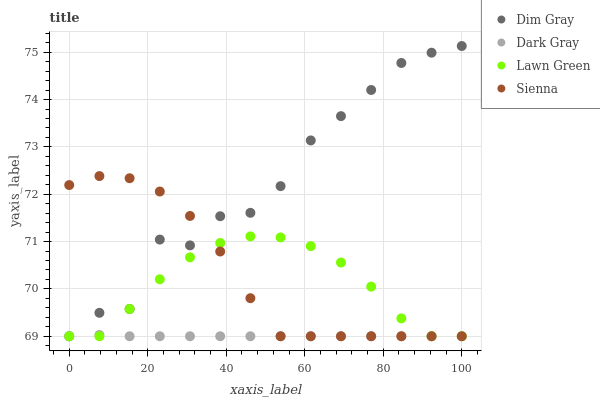Does Dark Gray have the minimum area under the curve?
Answer yes or no. Yes. Does Dim Gray have the maximum area under the curve?
Answer yes or no. Yes. Does Lawn Green have the minimum area under the curve?
Answer yes or no. No. Does Lawn Green have the maximum area under the curve?
Answer yes or no. No. Is Dark Gray the smoothest?
Answer yes or no. Yes. Is Dim Gray the roughest?
Answer yes or no. Yes. Is Lawn Green the smoothest?
Answer yes or no. No. Is Lawn Green the roughest?
Answer yes or no. No. Does Dark Gray have the lowest value?
Answer yes or no. Yes. Does Dim Gray have the highest value?
Answer yes or no. Yes. Does Lawn Green have the highest value?
Answer yes or no. No. Does Dark Gray intersect Lawn Green?
Answer yes or no. Yes. Is Dark Gray less than Lawn Green?
Answer yes or no. No. Is Dark Gray greater than Lawn Green?
Answer yes or no. No. 